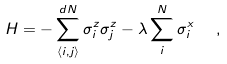Convert formula to latex. <formula><loc_0><loc_0><loc_500><loc_500>H = - \sum ^ { d N } _ { \langle { i } , { j } \rangle } \sigma ^ { z } _ { i } \sigma ^ { z } _ { j } - \lambda \sum ^ { N } _ { i } \sigma ^ { x } _ { i } \ \ ,</formula> 